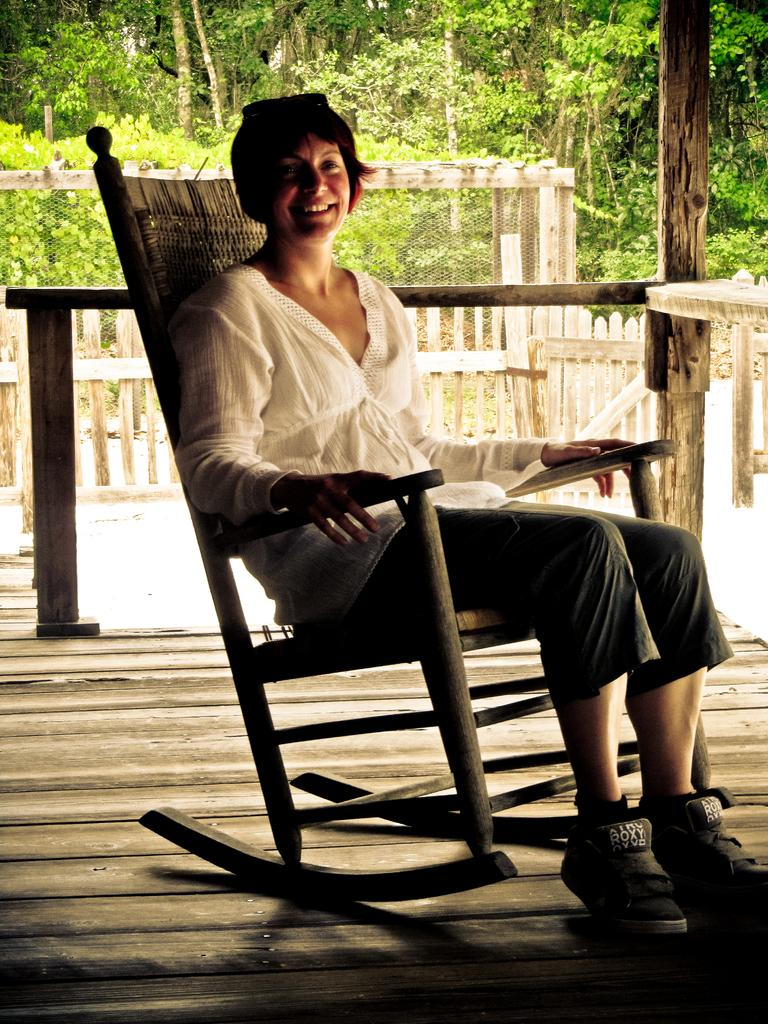Who is present in the image? There is a woman in the image. What is the woman doing in the image? The woman is sitting on a chair. What is the woman's facial expression in the image? The woman is smiling. What can be seen in the background of the image? There is a fence, a wooden pole, and trees in the background of the image. How many rings can be seen on the woman's fingers in the image? There is no mention of rings in the image, so we cannot determine the number of rings on the woman's fingers. What type of nut is growing on the wooden pole in the image? There is no nut growing on the wooden pole in the image; it is a wooden pole with no visible vegetation. 